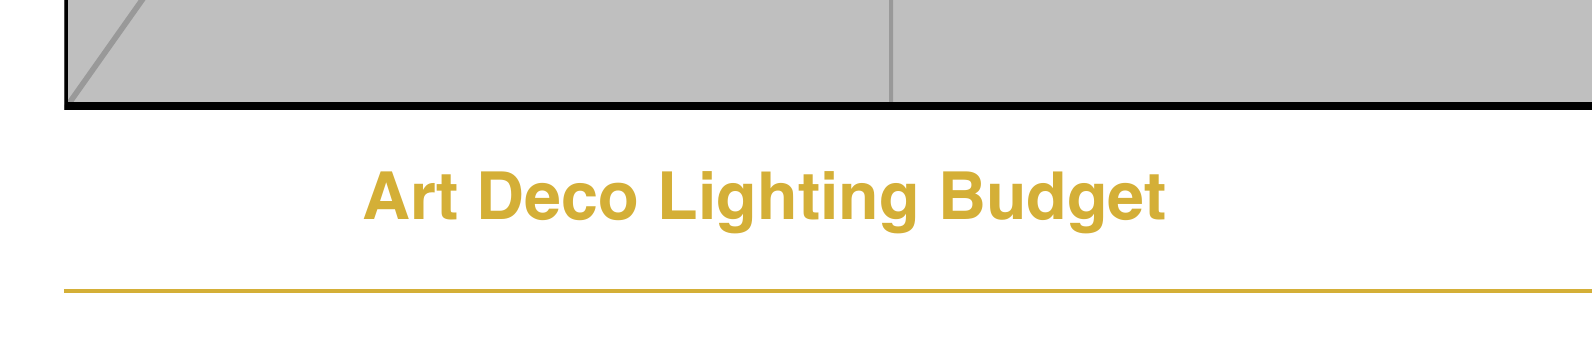What is the total budget for the lighting? The total budget is the sum of all the costs listed in the document, which is $131,000.
Answer: $131,000 How many Grand Ballroom Chandeliers are included? The document states that there is 1 Grand Ballroom Chandelier in the budget.
Answer: 1 What is the unit cost of the Lobby Tiered Chandeliers? According to the budget, the unit cost of the Lobby Tiered Chandeliers is $2,500.
Answer: $2,500 How many Geometric Brass Sconces are planned for use? The document lists 20 Geometric Brass Sconces in the lighting plan.
Answer: 20 What is the total cost of the Vintage-style Edison Bulbs? The total cost of the Vintage-style Edison Bulbs can be calculated as 100 bulbs at $15 each, totaling $1,500.
Answer: $1,500 What is the cost of the Lighting Designer Fee? The document specifies that the Lighting Designer Fee is $10,000.
Answer: $10,000 How many types of Specialty Lighting are included in the budget? There are two types of Specialty Lighting listed in the document: Art Deco Neon Signs and Backlit Stained Glass Panels.
Answer: 2 Which type of lighting has the highest unit cost? The document indicates that the Grand Ballroom Chandelier has the highest unit cost at $15,000.
Answer: Grand Ballroom Chandelier What is the total cost for installation and labor? The total cost for installation and labor is calculated by summing the Lighting Designer Fee ($10,000) and the Installation Team cost ($25,000), which equals $35,000.
Answer: $35,000 